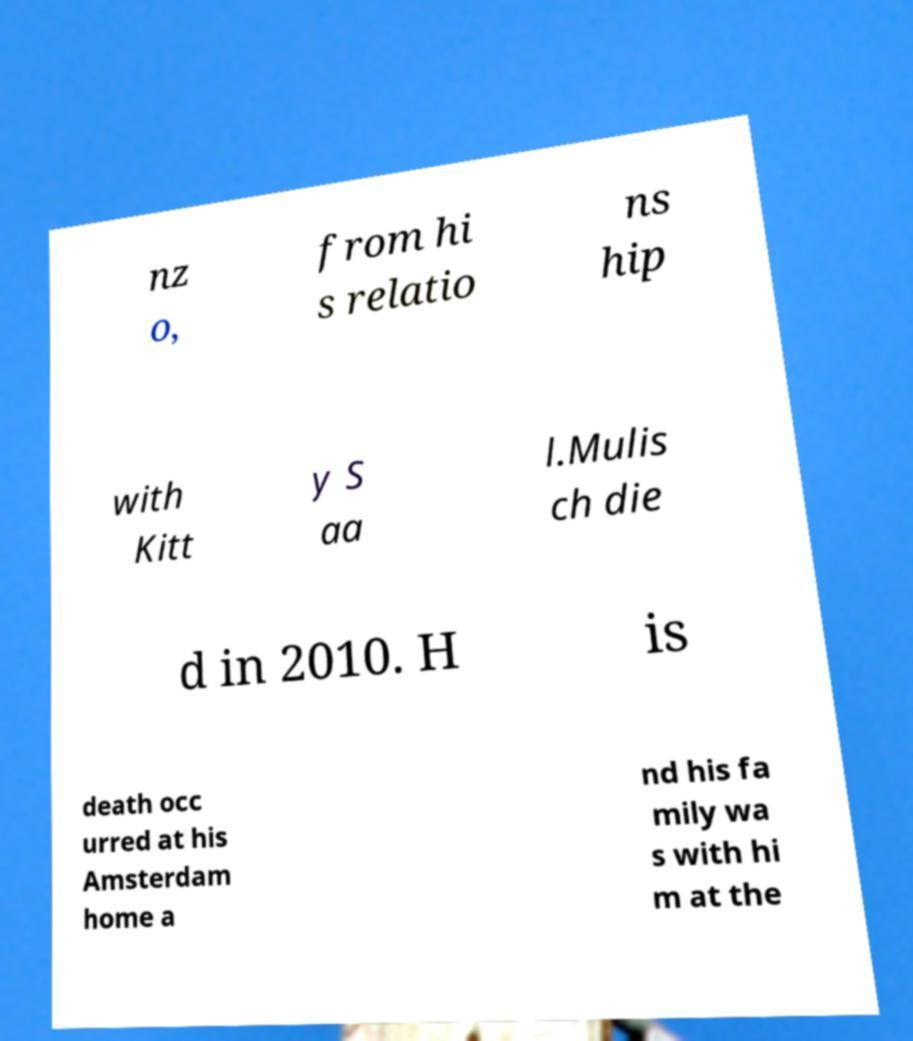Can you accurately transcribe the text from the provided image for me? nz o, from hi s relatio ns hip with Kitt y S aa l.Mulis ch die d in 2010. H is death occ urred at his Amsterdam home a nd his fa mily wa s with hi m at the 